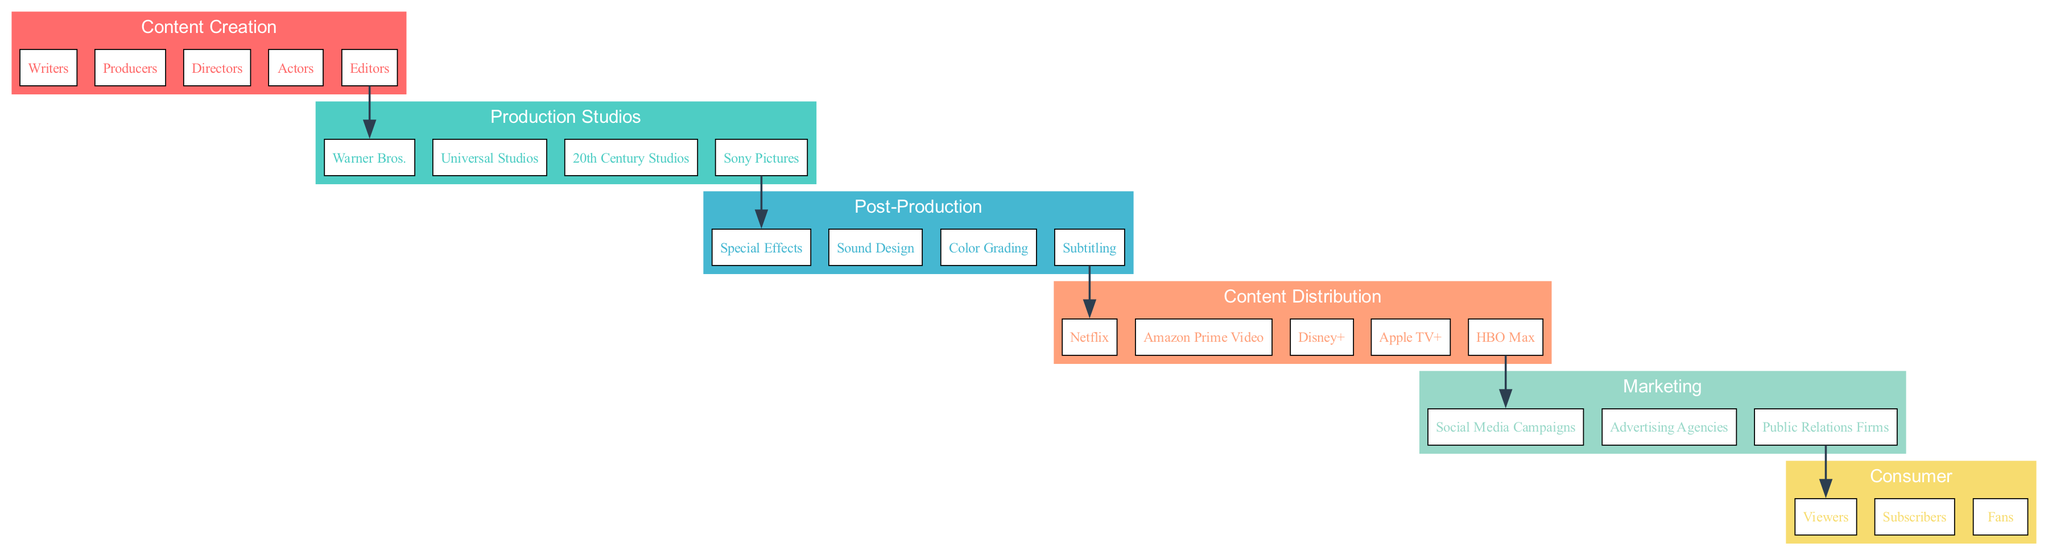What's the first stage in the supply chain? The supply chain's first stage is identified as "Content Creation," which includes various entities involved in creating media content.
Answer: Content Creation How many entities are listed in the Production Studios stage? The Production Studios stage includes four entities: Warner Bros., Universal Studios, 20th Century Studios, and Sony Pictures. Therefore, the count of entities is four.
Answer: Four Which platform is listed in the Content Distribution stage? The Content Distribution stage includes multiple platforms, and one of them is Netflix, which is explicitly mentioned as a key entity for streaming content.
Answer: Netflix Which entity bridges the gap between Content Creation and Post-Production? The flow between Content Creation and Post-Production shows that the last entity in Content Creation is "Editors," and this entity leads to the first entity in Post-Production.
Answer: Editors What is the predominant focus of the Marketing stage? The Marketing stage primarily focuses on social media campaigns, advertising agencies, and public relations firms as means to promote the media content to audiences.
Answer: Promotion How many stages are there in the entire supply chain? By examining the diagram, it can be noted that there are six distinct stages present in the supply chain from Content Creation to Consumer.
Answer: Six What is the relationship between Production Studios and Content Distribution? The relationship is indirect; Production Studios produce content, while Content Distribution platforms, such as Netflix, are responsible for streaming that content to the audience.
Answer: Indirect Which entities are categorized as Consumers? The Consumer stage includes individuals listed as Viewers, Subscribers, and Fans, who interact with the media.
Answer: Viewers, Subscribers, Fans What processes take place during the Post-Production stage? The Post-Production stage refers to essential processes like Special Effects, Sound Design, and Color Grading that enhance the created content before it is distributed.
Answer: Special Effects, Sound Design, Color Grading 